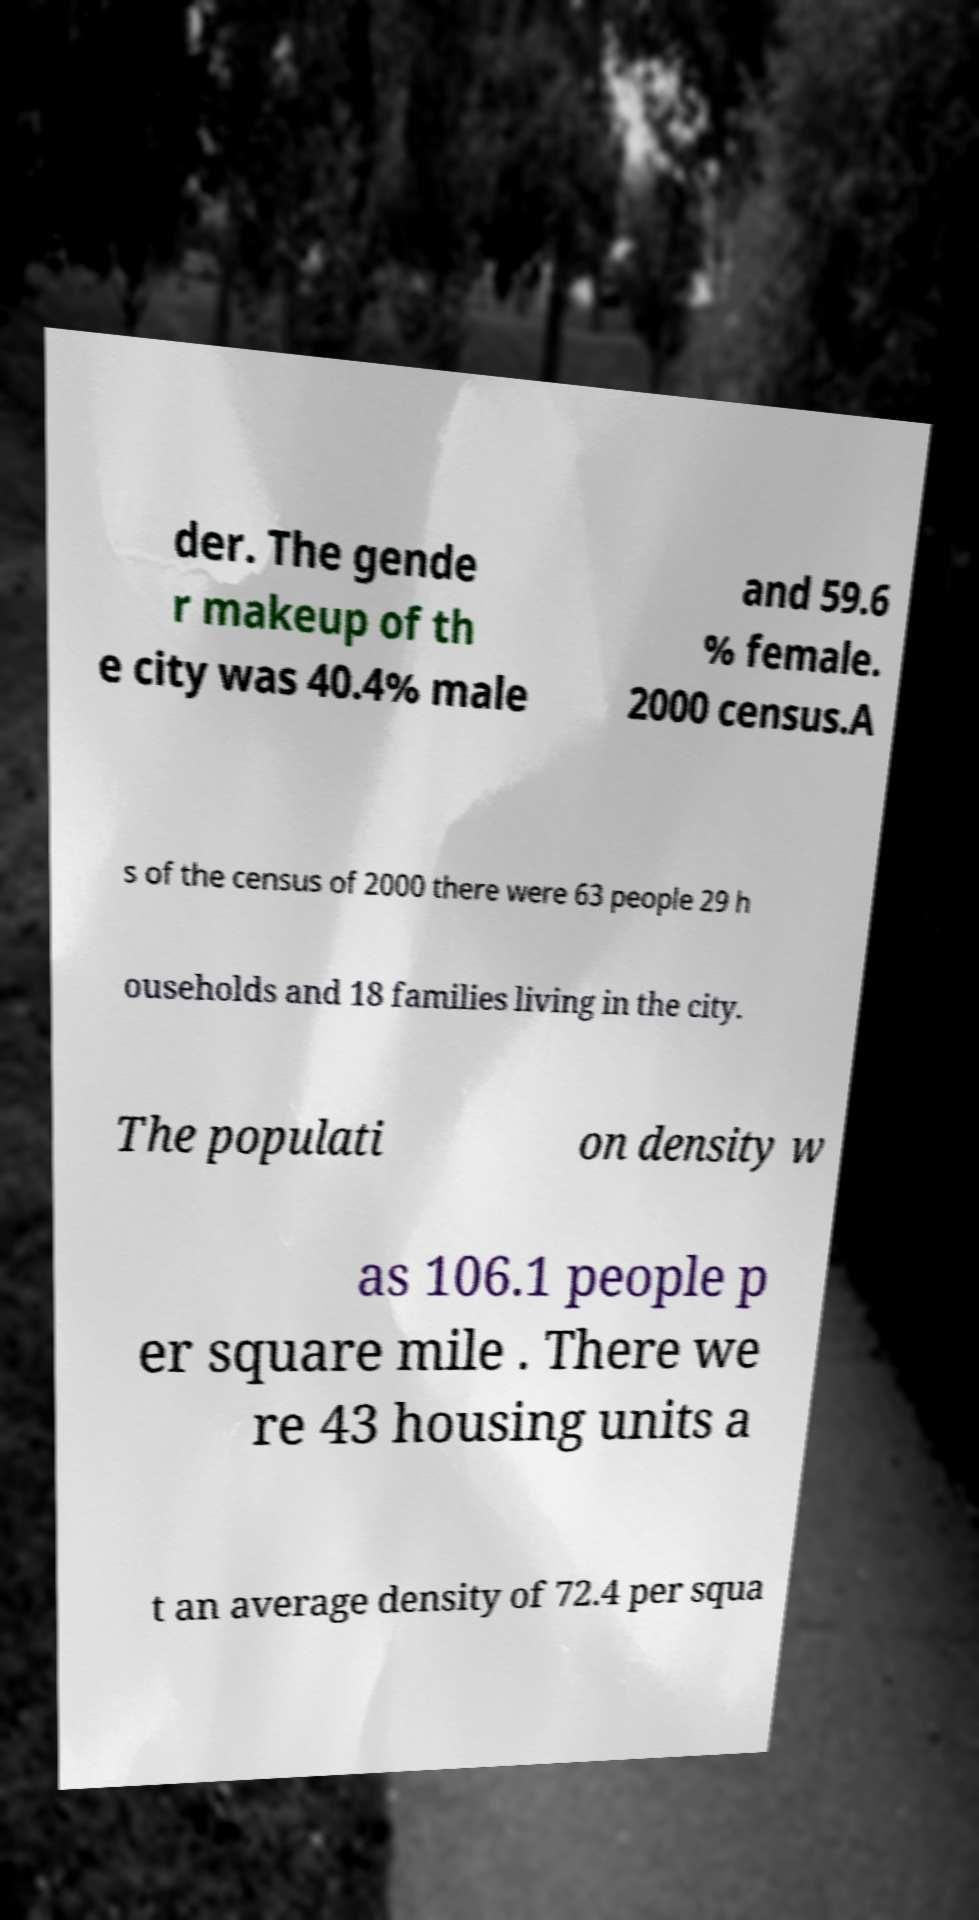Please read and relay the text visible in this image. What does it say? der. The gende r makeup of th e city was 40.4% male and 59.6 % female. 2000 census.A s of the census of 2000 there were 63 people 29 h ouseholds and 18 families living in the city. The populati on density w as 106.1 people p er square mile . There we re 43 housing units a t an average density of 72.4 per squa 